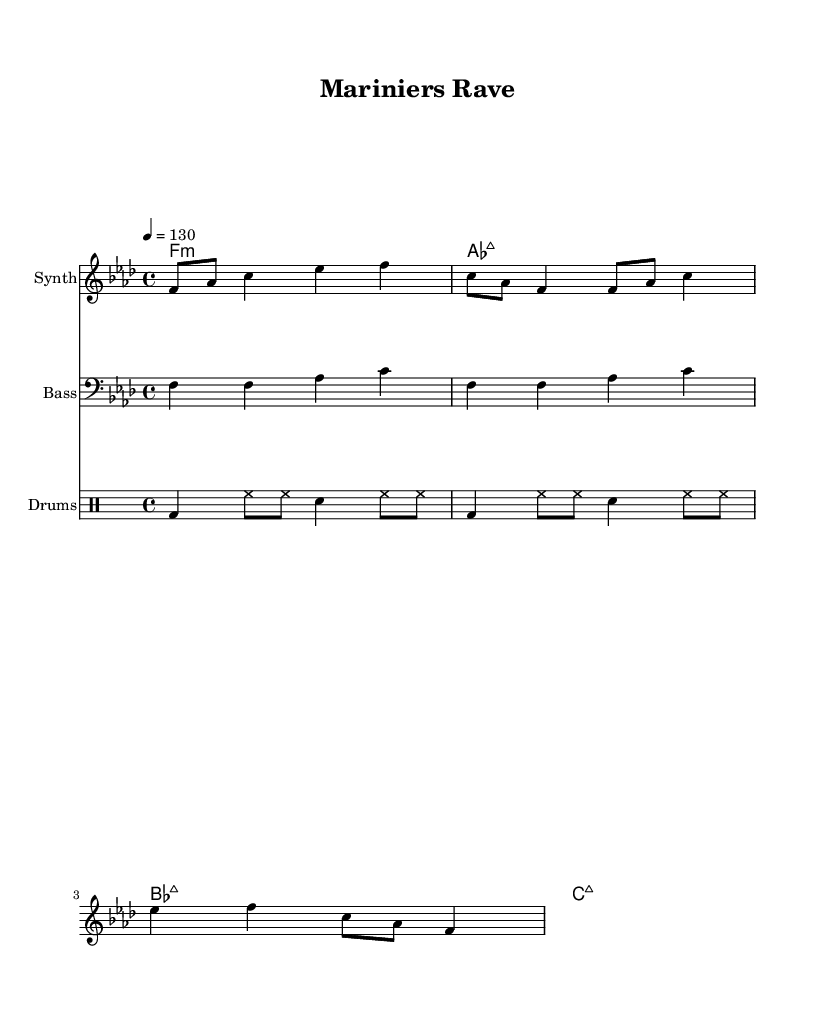What is the key signature of this music? The key signature shows four flats, indicating it is in the key of F minor.
Answer: F minor What is the time signature of the piece? The time signature is indicated at the beginning of the score as 4/4, which means there are four beats in a measure.
Answer: 4/4 What is the tempo of this dance music? The tempo marking indicates the piece should be played at 130 beats per minute, as denoted by "4 = 130".
Answer: 130 How many beats are in each measure of the synth melody? The piece is in 4/4 time, which means each measure contains four beats. Therefore, the synth melody conforms to this structure with four beats per measure.
Answer: Four Which instrument plays the bassline? The bassline is written in the bass clef, indicating it is performed by a bass instrument, specifically mentioned as "Bass" in the score.
Answer: Bass What is the pattern of the drum rhythm in the first two measures? The drum part consists of a kick drum on the first beat (bd), followed by eight notes played on the hi-hat (hh), and a snare on the third beat. This alternating pattern continues through the two measures.
Answer: Alternating pattern How does the chord structure support the dance music genre? The chord structure consists of minor and major chords, which creates a progressive, uplifting feel typical in dance music, contributing to its energetic atmosphere.
Answer: Minor and major chords 